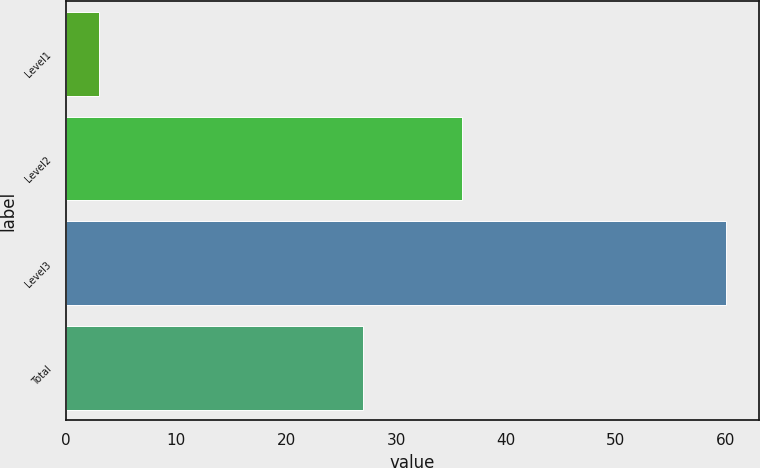<chart> <loc_0><loc_0><loc_500><loc_500><bar_chart><fcel>Level1<fcel>Level2<fcel>Level3<fcel>Total<nl><fcel>3<fcel>36<fcel>60<fcel>27<nl></chart> 